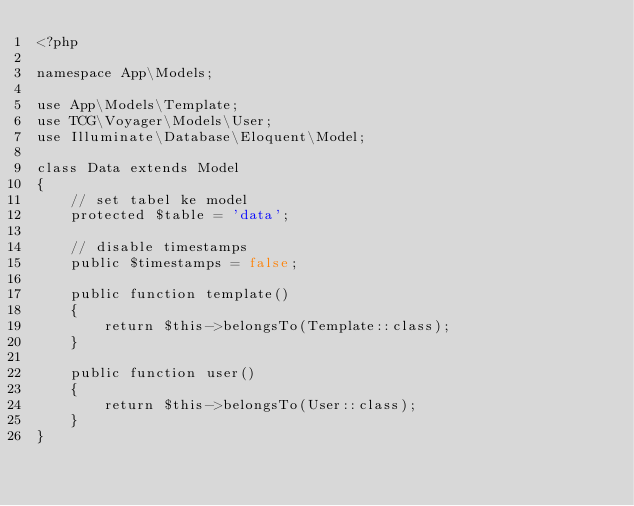<code> <loc_0><loc_0><loc_500><loc_500><_PHP_><?php

namespace App\Models;

use App\Models\Template;
use TCG\Voyager\Models\User;
use Illuminate\Database\Eloquent\Model;

class Data extends Model
{
    // set tabel ke model
    protected $table = 'data';

    // disable timestamps
    public $timestamps = false;

    public function template()
    {
        return $this->belongsTo(Template::class);
    }

    public function user()
    {
        return $this->belongsTo(User::class);
    }
}
</code> 